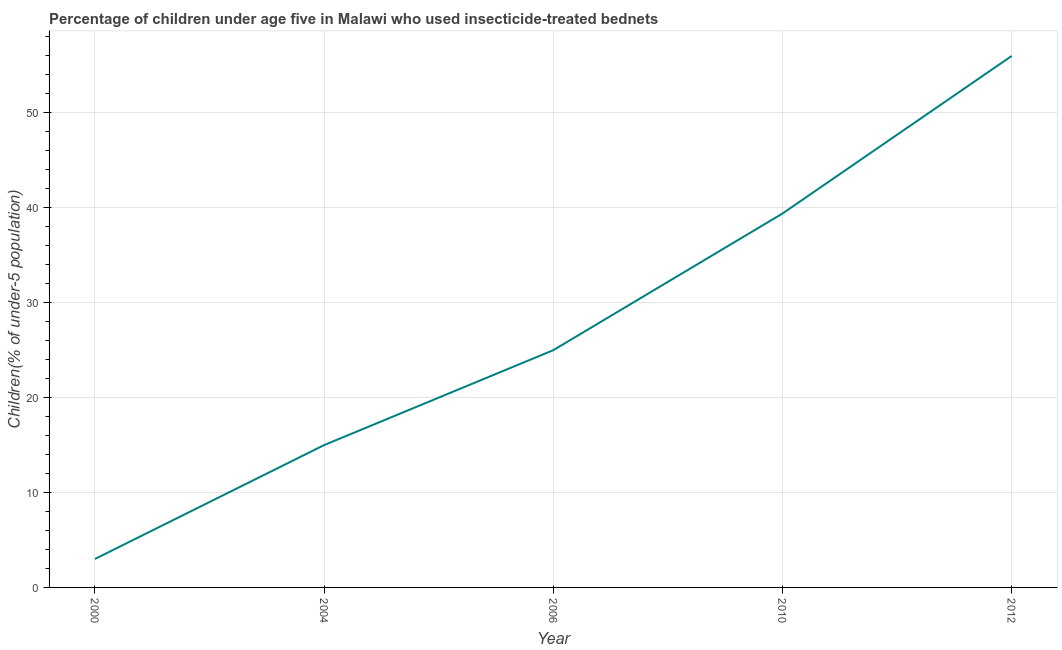In which year was the percentage of children who use of insecticide-treated bed nets minimum?
Provide a succinct answer. 2000. What is the sum of the percentage of children who use of insecticide-treated bed nets?
Your answer should be compact. 138.4. What is the difference between the percentage of children who use of insecticide-treated bed nets in 2000 and 2012?
Offer a very short reply. -53. What is the average percentage of children who use of insecticide-treated bed nets per year?
Keep it short and to the point. 27.68. What is the median percentage of children who use of insecticide-treated bed nets?
Keep it short and to the point. 25. Is the difference between the percentage of children who use of insecticide-treated bed nets in 2004 and 2012 greater than the difference between any two years?
Your answer should be very brief. No. What is the difference between the highest and the second highest percentage of children who use of insecticide-treated bed nets?
Give a very brief answer. 16.6. Is the sum of the percentage of children who use of insecticide-treated bed nets in 2000 and 2012 greater than the maximum percentage of children who use of insecticide-treated bed nets across all years?
Offer a terse response. Yes. How many lines are there?
Keep it short and to the point. 1. How many years are there in the graph?
Provide a succinct answer. 5. Are the values on the major ticks of Y-axis written in scientific E-notation?
Keep it short and to the point. No. Does the graph contain grids?
Provide a short and direct response. Yes. What is the title of the graph?
Provide a succinct answer. Percentage of children under age five in Malawi who used insecticide-treated bednets. What is the label or title of the Y-axis?
Give a very brief answer. Children(% of under-5 population). What is the Children(% of under-5 population) in 2000?
Make the answer very short. 3. What is the Children(% of under-5 population) of 2006?
Offer a terse response. 25. What is the Children(% of under-5 population) in 2010?
Make the answer very short. 39.4. What is the Children(% of under-5 population) in 2012?
Provide a succinct answer. 56. What is the difference between the Children(% of under-5 population) in 2000 and 2004?
Make the answer very short. -12. What is the difference between the Children(% of under-5 population) in 2000 and 2006?
Offer a terse response. -22. What is the difference between the Children(% of under-5 population) in 2000 and 2010?
Offer a very short reply. -36.4. What is the difference between the Children(% of under-5 population) in 2000 and 2012?
Make the answer very short. -53. What is the difference between the Children(% of under-5 population) in 2004 and 2006?
Give a very brief answer. -10. What is the difference between the Children(% of under-5 population) in 2004 and 2010?
Your answer should be compact. -24.4. What is the difference between the Children(% of under-5 population) in 2004 and 2012?
Give a very brief answer. -41. What is the difference between the Children(% of under-5 population) in 2006 and 2010?
Offer a very short reply. -14.4. What is the difference between the Children(% of under-5 population) in 2006 and 2012?
Provide a short and direct response. -31. What is the difference between the Children(% of under-5 population) in 2010 and 2012?
Keep it short and to the point. -16.6. What is the ratio of the Children(% of under-5 population) in 2000 to that in 2006?
Your answer should be compact. 0.12. What is the ratio of the Children(% of under-5 population) in 2000 to that in 2010?
Offer a very short reply. 0.08. What is the ratio of the Children(% of under-5 population) in 2000 to that in 2012?
Your answer should be compact. 0.05. What is the ratio of the Children(% of under-5 population) in 2004 to that in 2010?
Your answer should be compact. 0.38. What is the ratio of the Children(% of under-5 population) in 2004 to that in 2012?
Provide a short and direct response. 0.27. What is the ratio of the Children(% of under-5 population) in 2006 to that in 2010?
Ensure brevity in your answer.  0.64. What is the ratio of the Children(% of under-5 population) in 2006 to that in 2012?
Provide a short and direct response. 0.45. What is the ratio of the Children(% of under-5 population) in 2010 to that in 2012?
Provide a short and direct response. 0.7. 